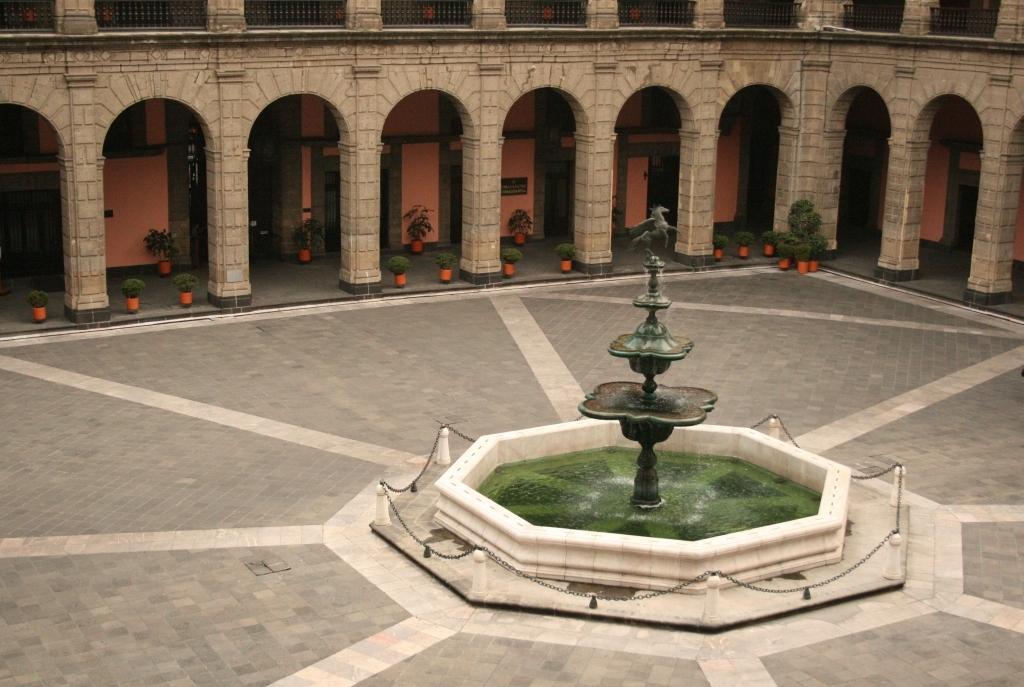How would you summarize this image in a sentence or two? This is a building. I think this is a fountain with a sculpture of a horse on it. These are the water. I can see the pillars. These look like the small flower pots with the plants in it. At the top of the image, I can see the iron grilles. These are the iron chains, which are hanging to the small poles. 